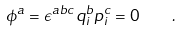<formula> <loc_0><loc_0><loc_500><loc_500>\phi ^ { a } = \epsilon ^ { a b c } q ^ { b } _ { i } p ^ { c } _ { i } = 0 \quad .</formula> 